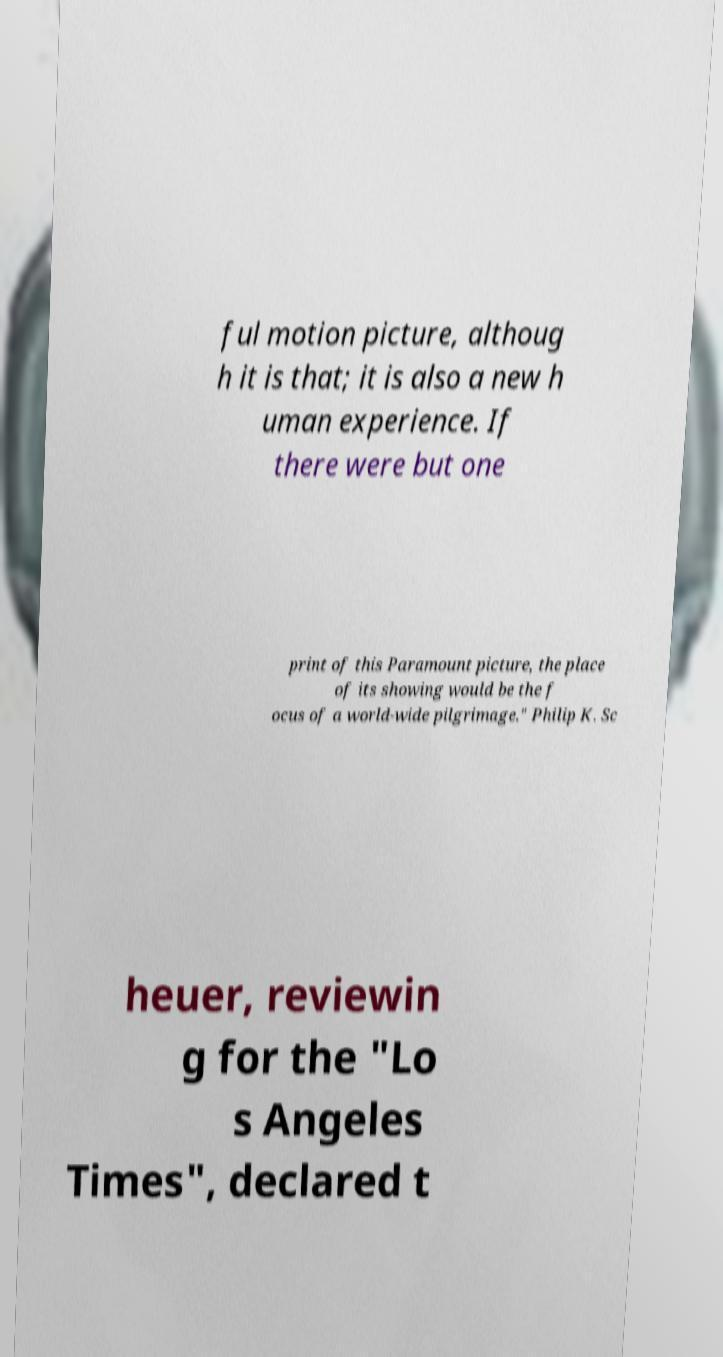Could you extract and type out the text from this image? ful motion picture, althoug h it is that; it is also a new h uman experience. If there were but one print of this Paramount picture, the place of its showing would be the f ocus of a world-wide pilgrimage." Philip K. Sc heuer, reviewin g for the "Lo s Angeles Times", declared t 